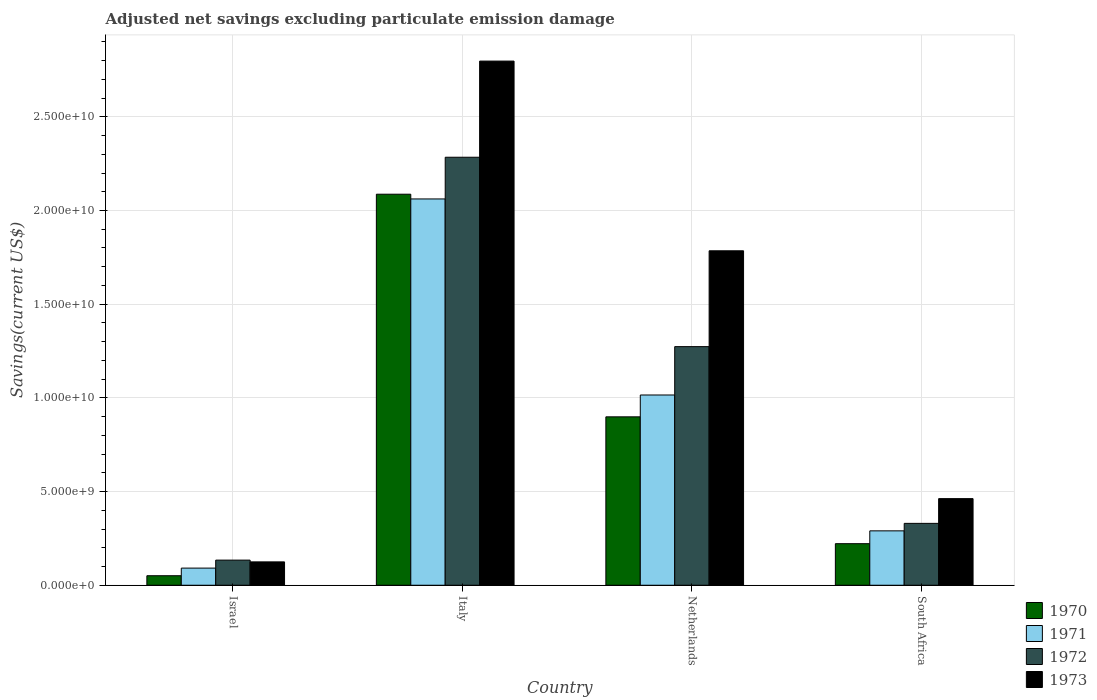How many different coloured bars are there?
Your answer should be compact. 4. How many groups of bars are there?
Provide a succinct answer. 4. How many bars are there on the 2nd tick from the left?
Make the answer very short. 4. What is the label of the 1st group of bars from the left?
Your answer should be very brief. Israel. What is the adjusted net savings in 1973 in South Africa?
Offer a very short reply. 4.62e+09. Across all countries, what is the maximum adjusted net savings in 1973?
Ensure brevity in your answer.  2.80e+1. Across all countries, what is the minimum adjusted net savings in 1970?
Offer a very short reply. 5.08e+08. What is the total adjusted net savings in 1971 in the graph?
Offer a very short reply. 3.46e+1. What is the difference between the adjusted net savings in 1970 in Israel and that in Italy?
Provide a succinct answer. -2.04e+1. What is the difference between the adjusted net savings in 1973 in Netherlands and the adjusted net savings in 1970 in Italy?
Make the answer very short. -3.02e+09. What is the average adjusted net savings in 1970 per country?
Offer a very short reply. 8.15e+09. What is the difference between the adjusted net savings of/in 1971 and adjusted net savings of/in 1973 in Israel?
Provide a short and direct response. -3.33e+08. In how many countries, is the adjusted net savings in 1971 greater than 23000000000 US$?
Offer a terse response. 0. What is the ratio of the adjusted net savings in 1970 in Italy to that in Netherlands?
Offer a very short reply. 2.32. Is the adjusted net savings in 1972 in Italy less than that in South Africa?
Ensure brevity in your answer.  No. What is the difference between the highest and the second highest adjusted net savings in 1972?
Offer a very short reply. -1.95e+1. What is the difference between the highest and the lowest adjusted net savings in 1972?
Your response must be concise. 2.15e+1. Is it the case that in every country, the sum of the adjusted net savings in 1973 and adjusted net savings in 1972 is greater than the sum of adjusted net savings in 1970 and adjusted net savings in 1971?
Provide a succinct answer. No. What does the 1st bar from the right in Italy represents?
Your response must be concise. 1973. Is it the case that in every country, the sum of the adjusted net savings in 1972 and adjusted net savings in 1970 is greater than the adjusted net savings in 1973?
Provide a short and direct response. Yes. Are all the bars in the graph horizontal?
Your response must be concise. No. Does the graph contain grids?
Your answer should be compact. Yes. Where does the legend appear in the graph?
Your response must be concise. Bottom right. What is the title of the graph?
Provide a short and direct response. Adjusted net savings excluding particulate emission damage. Does "1984" appear as one of the legend labels in the graph?
Provide a short and direct response. No. What is the label or title of the Y-axis?
Make the answer very short. Savings(current US$). What is the Savings(current US$) in 1970 in Israel?
Provide a short and direct response. 5.08e+08. What is the Savings(current US$) of 1971 in Israel?
Give a very brief answer. 9.14e+08. What is the Savings(current US$) in 1972 in Israel?
Offer a terse response. 1.34e+09. What is the Savings(current US$) of 1973 in Israel?
Your response must be concise. 1.25e+09. What is the Savings(current US$) in 1970 in Italy?
Provide a short and direct response. 2.09e+1. What is the Savings(current US$) of 1971 in Italy?
Keep it short and to the point. 2.06e+1. What is the Savings(current US$) in 1972 in Italy?
Offer a terse response. 2.28e+1. What is the Savings(current US$) of 1973 in Italy?
Provide a succinct answer. 2.80e+1. What is the Savings(current US$) of 1970 in Netherlands?
Your answer should be compact. 8.99e+09. What is the Savings(current US$) in 1971 in Netherlands?
Offer a very short reply. 1.02e+1. What is the Savings(current US$) in 1972 in Netherlands?
Provide a succinct answer. 1.27e+1. What is the Savings(current US$) in 1973 in Netherlands?
Your response must be concise. 1.79e+1. What is the Savings(current US$) in 1970 in South Africa?
Offer a very short reply. 2.22e+09. What is the Savings(current US$) of 1971 in South Africa?
Your answer should be very brief. 2.90e+09. What is the Savings(current US$) of 1972 in South Africa?
Offer a very short reply. 3.30e+09. What is the Savings(current US$) in 1973 in South Africa?
Give a very brief answer. 4.62e+09. Across all countries, what is the maximum Savings(current US$) in 1970?
Provide a short and direct response. 2.09e+1. Across all countries, what is the maximum Savings(current US$) in 1971?
Offer a terse response. 2.06e+1. Across all countries, what is the maximum Savings(current US$) of 1972?
Your answer should be very brief. 2.28e+1. Across all countries, what is the maximum Savings(current US$) in 1973?
Ensure brevity in your answer.  2.80e+1. Across all countries, what is the minimum Savings(current US$) of 1970?
Your answer should be very brief. 5.08e+08. Across all countries, what is the minimum Savings(current US$) in 1971?
Your answer should be very brief. 9.14e+08. Across all countries, what is the minimum Savings(current US$) in 1972?
Ensure brevity in your answer.  1.34e+09. Across all countries, what is the minimum Savings(current US$) of 1973?
Keep it short and to the point. 1.25e+09. What is the total Savings(current US$) of 1970 in the graph?
Your answer should be very brief. 3.26e+1. What is the total Savings(current US$) of 1971 in the graph?
Your answer should be very brief. 3.46e+1. What is the total Savings(current US$) in 1972 in the graph?
Ensure brevity in your answer.  4.02e+1. What is the total Savings(current US$) of 1973 in the graph?
Your response must be concise. 5.17e+1. What is the difference between the Savings(current US$) in 1970 in Israel and that in Italy?
Your answer should be compact. -2.04e+1. What is the difference between the Savings(current US$) of 1971 in Israel and that in Italy?
Provide a short and direct response. -1.97e+1. What is the difference between the Savings(current US$) of 1972 in Israel and that in Italy?
Keep it short and to the point. -2.15e+1. What is the difference between the Savings(current US$) in 1973 in Israel and that in Italy?
Offer a very short reply. -2.67e+1. What is the difference between the Savings(current US$) in 1970 in Israel and that in Netherlands?
Provide a short and direct response. -8.48e+09. What is the difference between the Savings(current US$) in 1971 in Israel and that in Netherlands?
Ensure brevity in your answer.  -9.24e+09. What is the difference between the Savings(current US$) in 1972 in Israel and that in Netherlands?
Keep it short and to the point. -1.14e+1. What is the difference between the Savings(current US$) in 1973 in Israel and that in Netherlands?
Provide a short and direct response. -1.66e+1. What is the difference between the Savings(current US$) in 1970 in Israel and that in South Africa?
Offer a terse response. -1.71e+09. What is the difference between the Savings(current US$) of 1971 in Israel and that in South Africa?
Offer a terse response. -1.99e+09. What is the difference between the Savings(current US$) in 1972 in Israel and that in South Africa?
Ensure brevity in your answer.  -1.96e+09. What is the difference between the Savings(current US$) in 1973 in Israel and that in South Africa?
Your answer should be compact. -3.38e+09. What is the difference between the Savings(current US$) of 1970 in Italy and that in Netherlands?
Keep it short and to the point. 1.19e+1. What is the difference between the Savings(current US$) of 1971 in Italy and that in Netherlands?
Offer a terse response. 1.05e+1. What is the difference between the Savings(current US$) of 1972 in Italy and that in Netherlands?
Your answer should be compact. 1.01e+1. What is the difference between the Savings(current US$) of 1973 in Italy and that in Netherlands?
Offer a very short reply. 1.01e+1. What is the difference between the Savings(current US$) in 1970 in Italy and that in South Africa?
Offer a very short reply. 1.87e+1. What is the difference between the Savings(current US$) of 1971 in Italy and that in South Africa?
Your response must be concise. 1.77e+1. What is the difference between the Savings(current US$) of 1972 in Italy and that in South Africa?
Make the answer very short. 1.95e+1. What is the difference between the Savings(current US$) of 1973 in Italy and that in South Africa?
Offer a very short reply. 2.34e+1. What is the difference between the Savings(current US$) in 1970 in Netherlands and that in South Africa?
Your answer should be compact. 6.77e+09. What is the difference between the Savings(current US$) of 1971 in Netherlands and that in South Africa?
Your answer should be very brief. 7.25e+09. What is the difference between the Savings(current US$) of 1972 in Netherlands and that in South Africa?
Keep it short and to the point. 9.43e+09. What is the difference between the Savings(current US$) of 1973 in Netherlands and that in South Africa?
Your response must be concise. 1.32e+1. What is the difference between the Savings(current US$) of 1970 in Israel and the Savings(current US$) of 1971 in Italy?
Keep it short and to the point. -2.01e+1. What is the difference between the Savings(current US$) in 1970 in Israel and the Savings(current US$) in 1972 in Italy?
Your answer should be very brief. -2.23e+1. What is the difference between the Savings(current US$) in 1970 in Israel and the Savings(current US$) in 1973 in Italy?
Give a very brief answer. -2.75e+1. What is the difference between the Savings(current US$) in 1971 in Israel and the Savings(current US$) in 1972 in Italy?
Provide a short and direct response. -2.19e+1. What is the difference between the Savings(current US$) in 1971 in Israel and the Savings(current US$) in 1973 in Italy?
Give a very brief answer. -2.71e+1. What is the difference between the Savings(current US$) of 1972 in Israel and the Savings(current US$) of 1973 in Italy?
Offer a terse response. -2.66e+1. What is the difference between the Savings(current US$) in 1970 in Israel and the Savings(current US$) in 1971 in Netherlands?
Your answer should be compact. -9.65e+09. What is the difference between the Savings(current US$) of 1970 in Israel and the Savings(current US$) of 1972 in Netherlands?
Your answer should be very brief. -1.22e+1. What is the difference between the Savings(current US$) of 1970 in Israel and the Savings(current US$) of 1973 in Netherlands?
Ensure brevity in your answer.  -1.73e+1. What is the difference between the Savings(current US$) in 1971 in Israel and the Savings(current US$) in 1972 in Netherlands?
Make the answer very short. -1.18e+1. What is the difference between the Savings(current US$) of 1971 in Israel and the Savings(current US$) of 1973 in Netherlands?
Offer a very short reply. -1.69e+1. What is the difference between the Savings(current US$) in 1972 in Israel and the Savings(current US$) in 1973 in Netherlands?
Provide a short and direct response. -1.65e+1. What is the difference between the Savings(current US$) in 1970 in Israel and the Savings(current US$) in 1971 in South Africa?
Offer a terse response. -2.39e+09. What is the difference between the Savings(current US$) in 1970 in Israel and the Savings(current US$) in 1972 in South Africa?
Make the answer very short. -2.79e+09. What is the difference between the Savings(current US$) of 1970 in Israel and the Savings(current US$) of 1973 in South Africa?
Your answer should be compact. -4.11e+09. What is the difference between the Savings(current US$) in 1971 in Israel and the Savings(current US$) in 1972 in South Africa?
Offer a terse response. -2.39e+09. What is the difference between the Savings(current US$) in 1971 in Israel and the Savings(current US$) in 1973 in South Africa?
Give a very brief answer. -3.71e+09. What is the difference between the Savings(current US$) in 1972 in Israel and the Savings(current US$) in 1973 in South Africa?
Offer a very short reply. -3.28e+09. What is the difference between the Savings(current US$) of 1970 in Italy and the Savings(current US$) of 1971 in Netherlands?
Your answer should be very brief. 1.07e+1. What is the difference between the Savings(current US$) in 1970 in Italy and the Savings(current US$) in 1972 in Netherlands?
Your answer should be compact. 8.14e+09. What is the difference between the Savings(current US$) in 1970 in Italy and the Savings(current US$) in 1973 in Netherlands?
Offer a terse response. 3.02e+09. What is the difference between the Savings(current US$) in 1971 in Italy and the Savings(current US$) in 1972 in Netherlands?
Your answer should be compact. 7.88e+09. What is the difference between the Savings(current US$) in 1971 in Italy and the Savings(current US$) in 1973 in Netherlands?
Ensure brevity in your answer.  2.77e+09. What is the difference between the Savings(current US$) of 1972 in Italy and the Savings(current US$) of 1973 in Netherlands?
Make the answer very short. 4.99e+09. What is the difference between the Savings(current US$) of 1970 in Italy and the Savings(current US$) of 1971 in South Africa?
Provide a succinct answer. 1.80e+1. What is the difference between the Savings(current US$) of 1970 in Italy and the Savings(current US$) of 1972 in South Africa?
Keep it short and to the point. 1.76e+1. What is the difference between the Savings(current US$) in 1970 in Italy and the Savings(current US$) in 1973 in South Africa?
Make the answer very short. 1.62e+1. What is the difference between the Savings(current US$) of 1971 in Italy and the Savings(current US$) of 1972 in South Africa?
Provide a short and direct response. 1.73e+1. What is the difference between the Savings(current US$) of 1971 in Italy and the Savings(current US$) of 1973 in South Africa?
Give a very brief answer. 1.60e+1. What is the difference between the Savings(current US$) in 1972 in Italy and the Savings(current US$) in 1973 in South Africa?
Your answer should be very brief. 1.82e+1. What is the difference between the Savings(current US$) of 1970 in Netherlands and the Savings(current US$) of 1971 in South Africa?
Your response must be concise. 6.09e+09. What is the difference between the Savings(current US$) in 1970 in Netherlands and the Savings(current US$) in 1972 in South Africa?
Provide a short and direct response. 5.69e+09. What is the difference between the Savings(current US$) of 1970 in Netherlands and the Savings(current US$) of 1973 in South Africa?
Your answer should be compact. 4.37e+09. What is the difference between the Savings(current US$) in 1971 in Netherlands and the Savings(current US$) in 1972 in South Africa?
Your response must be concise. 6.85e+09. What is the difference between the Savings(current US$) in 1971 in Netherlands and the Savings(current US$) in 1973 in South Africa?
Give a very brief answer. 5.53e+09. What is the difference between the Savings(current US$) of 1972 in Netherlands and the Savings(current US$) of 1973 in South Africa?
Keep it short and to the point. 8.11e+09. What is the average Savings(current US$) in 1970 per country?
Provide a short and direct response. 8.15e+09. What is the average Savings(current US$) in 1971 per country?
Ensure brevity in your answer.  8.65e+09. What is the average Savings(current US$) of 1972 per country?
Your response must be concise. 1.01e+1. What is the average Savings(current US$) in 1973 per country?
Keep it short and to the point. 1.29e+1. What is the difference between the Savings(current US$) of 1970 and Savings(current US$) of 1971 in Israel?
Your answer should be compact. -4.06e+08. What is the difference between the Savings(current US$) in 1970 and Savings(current US$) in 1972 in Israel?
Your response must be concise. -8.33e+08. What is the difference between the Savings(current US$) of 1970 and Savings(current US$) of 1973 in Israel?
Keep it short and to the point. -7.39e+08. What is the difference between the Savings(current US$) of 1971 and Savings(current US$) of 1972 in Israel?
Provide a succinct answer. -4.27e+08. What is the difference between the Savings(current US$) in 1971 and Savings(current US$) in 1973 in Israel?
Make the answer very short. -3.33e+08. What is the difference between the Savings(current US$) in 1972 and Savings(current US$) in 1973 in Israel?
Your response must be concise. 9.40e+07. What is the difference between the Savings(current US$) of 1970 and Savings(current US$) of 1971 in Italy?
Offer a terse response. 2.53e+08. What is the difference between the Savings(current US$) in 1970 and Savings(current US$) in 1972 in Italy?
Ensure brevity in your answer.  -1.97e+09. What is the difference between the Savings(current US$) in 1970 and Savings(current US$) in 1973 in Italy?
Ensure brevity in your answer.  -7.11e+09. What is the difference between the Savings(current US$) in 1971 and Savings(current US$) in 1972 in Italy?
Give a very brief answer. -2.23e+09. What is the difference between the Savings(current US$) in 1971 and Savings(current US$) in 1973 in Italy?
Your answer should be very brief. -7.36e+09. What is the difference between the Savings(current US$) of 1972 and Savings(current US$) of 1973 in Italy?
Offer a very short reply. -5.13e+09. What is the difference between the Savings(current US$) of 1970 and Savings(current US$) of 1971 in Netherlands?
Give a very brief answer. -1.17e+09. What is the difference between the Savings(current US$) in 1970 and Savings(current US$) in 1972 in Netherlands?
Make the answer very short. -3.75e+09. What is the difference between the Savings(current US$) in 1970 and Savings(current US$) in 1973 in Netherlands?
Give a very brief answer. -8.86e+09. What is the difference between the Savings(current US$) in 1971 and Savings(current US$) in 1972 in Netherlands?
Ensure brevity in your answer.  -2.58e+09. What is the difference between the Savings(current US$) in 1971 and Savings(current US$) in 1973 in Netherlands?
Offer a very short reply. -7.70e+09. What is the difference between the Savings(current US$) in 1972 and Savings(current US$) in 1973 in Netherlands?
Provide a succinct answer. -5.11e+09. What is the difference between the Savings(current US$) in 1970 and Savings(current US$) in 1971 in South Africa?
Offer a terse response. -6.85e+08. What is the difference between the Savings(current US$) of 1970 and Savings(current US$) of 1972 in South Africa?
Keep it short and to the point. -1.08e+09. What is the difference between the Savings(current US$) in 1970 and Savings(current US$) in 1973 in South Africa?
Make the answer very short. -2.40e+09. What is the difference between the Savings(current US$) of 1971 and Savings(current US$) of 1972 in South Africa?
Provide a short and direct response. -4.00e+08. What is the difference between the Savings(current US$) in 1971 and Savings(current US$) in 1973 in South Africa?
Provide a short and direct response. -1.72e+09. What is the difference between the Savings(current US$) of 1972 and Savings(current US$) of 1973 in South Africa?
Your response must be concise. -1.32e+09. What is the ratio of the Savings(current US$) of 1970 in Israel to that in Italy?
Offer a terse response. 0.02. What is the ratio of the Savings(current US$) in 1971 in Israel to that in Italy?
Provide a succinct answer. 0.04. What is the ratio of the Savings(current US$) in 1972 in Israel to that in Italy?
Keep it short and to the point. 0.06. What is the ratio of the Savings(current US$) in 1973 in Israel to that in Italy?
Ensure brevity in your answer.  0.04. What is the ratio of the Savings(current US$) of 1970 in Israel to that in Netherlands?
Keep it short and to the point. 0.06. What is the ratio of the Savings(current US$) of 1971 in Israel to that in Netherlands?
Your answer should be compact. 0.09. What is the ratio of the Savings(current US$) in 1972 in Israel to that in Netherlands?
Provide a short and direct response. 0.11. What is the ratio of the Savings(current US$) of 1973 in Israel to that in Netherlands?
Provide a succinct answer. 0.07. What is the ratio of the Savings(current US$) of 1970 in Israel to that in South Africa?
Provide a succinct answer. 0.23. What is the ratio of the Savings(current US$) of 1971 in Israel to that in South Africa?
Your response must be concise. 0.32. What is the ratio of the Savings(current US$) of 1972 in Israel to that in South Africa?
Provide a succinct answer. 0.41. What is the ratio of the Savings(current US$) in 1973 in Israel to that in South Africa?
Provide a succinct answer. 0.27. What is the ratio of the Savings(current US$) of 1970 in Italy to that in Netherlands?
Offer a very short reply. 2.32. What is the ratio of the Savings(current US$) of 1971 in Italy to that in Netherlands?
Keep it short and to the point. 2.03. What is the ratio of the Savings(current US$) of 1972 in Italy to that in Netherlands?
Provide a short and direct response. 1.79. What is the ratio of the Savings(current US$) in 1973 in Italy to that in Netherlands?
Give a very brief answer. 1.57. What is the ratio of the Savings(current US$) in 1970 in Italy to that in South Africa?
Your response must be concise. 9.41. What is the ratio of the Savings(current US$) in 1971 in Italy to that in South Africa?
Ensure brevity in your answer.  7.1. What is the ratio of the Savings(current US$) in 1972 in Italy to that in South Africa?
Give a very brief answer. 6.92. What is the ratio of the Savings(current US$) in 1973 in Italy to that in South Africa?
Your response must be concise. 6.05. What is the ratio of the Savings(current US$) in 1970 in Netherlands to that in South Africa?
Provide a succinct answer. 4.05. What is the ratio of the Savings(current US$) of 1971 in Netherlands to that in South Africa?
Give a very brief answer. 3.5. What is the ratio of the Savings(current US$) in 1972 in Netherlands to that in South Africa?
Provide a succinct answer. 3.86. What is the ratio of the Savings(current US$) in 1973 in Netherlands to that in South Africa?
Offer a very short reply. 3.86. What is the difference between the highest and the second highest Savings(current US$) of 1970?
Your answer should be very brief. 1.19e+1. What is the difference between the highest and the second highest Savings(current US$) in 1971?
Provide a succinct answer. 1.05e+1. What is the difference between the highest and the second highest Savings(current US$) in 1972?
Your answer should be very brief. 1.01e+1. What is the difference between the highest and the second highest Savings(current US$) of 1973?
Keep it short and to the point. 1.01e+1. What is the difference between the highest and the lowest Savings(current US$) in 1970?
Make the answer very short. 2.04e+1. What is the difference between the highest and the lowest Savings(current US$) of 1971?
Your answer should be compact. 1.97e+1. What is the difference between the highest and the lowest Savings(current US$) of 1972?
Your answer should be compact. 2.15e+1. What is the difference between the highest and the lowest Savings(current US$) in 1973?
Keep it short and to the point. 2.67e+1. 